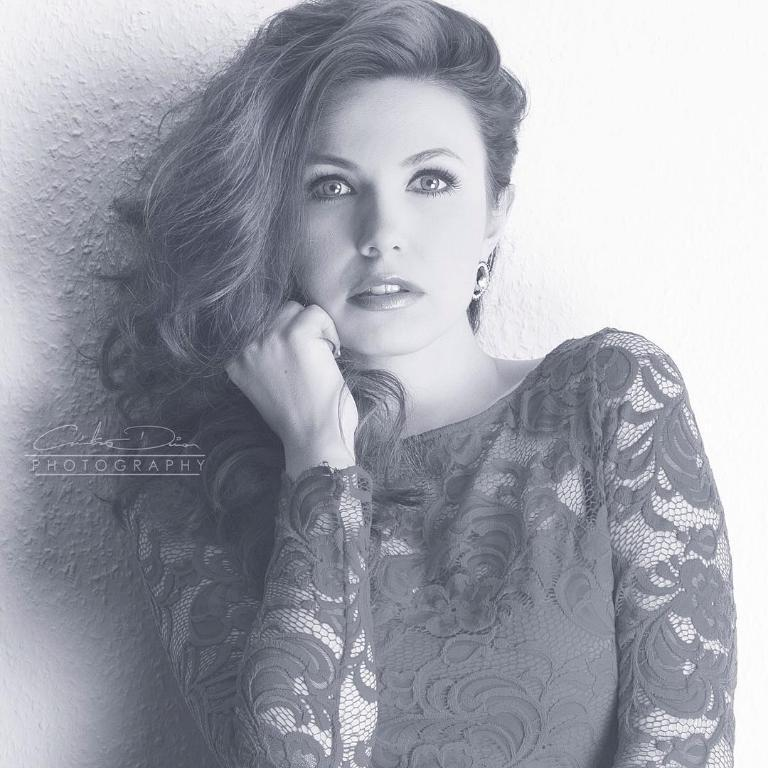Who is the main subject in the picture? There is a girl in the picture. What is the girl doing in the image? The girl is doing a pose. How is the girl holding her hair in the picture? The girl is holding her hair with her right hand. What type of current is flowing through the girl's skirt in the image? There is no mention of a skirt or current in the image, so this question cannot be answered definitively. 